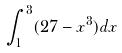<formula> <loc_0><loc_0><loc_500><loc_500>\int _ { 1 } ^ { 3 } ( 2 7 - x ^ { 3 } ) d x</formula> 